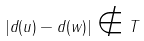<formula> <loc_0><loc_0><loc_500><loc_500>| d ( u ) - d ( w ) | \notin T</formula> 